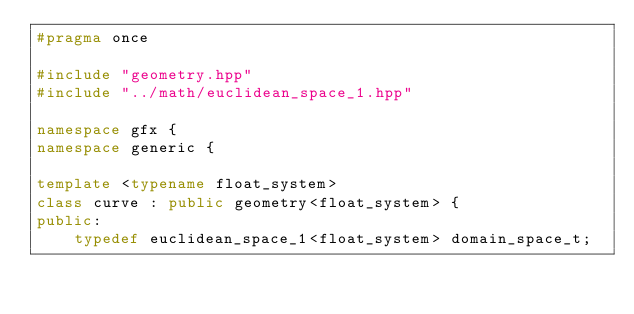<code> <loc_0><loc_0><loc_500><loc_500><_C++_>#pragma once

#include "geometry.hpp"
#include "../math/euclidean_space_1.hpp"

namespace gfx {
namespace generic {

template <typename float_system>
class curve : public geometry<float_system> {
public:
    typedef euclidean_space_1<float_system> domain_space_t;</code> 